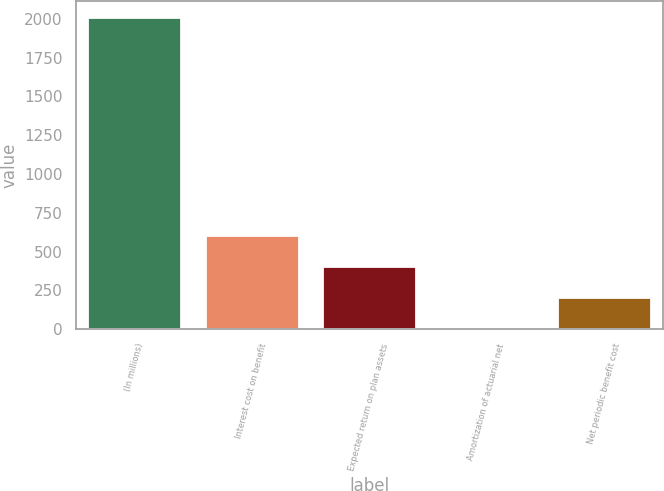<chart> <loc_0><loc_0><loc_500><loc_500><bar_chart><fcel>(In millions)<fcel>Interest cost on benefit<fcel>Expected return on plan assets<fcel>Amortization of actuarial net<fcel>Net periodic benefit cost<nl><fcel>2012<fcel>605.91<fcel>405.04<fcel>3.3<fcel>204.17<nl></chart> 